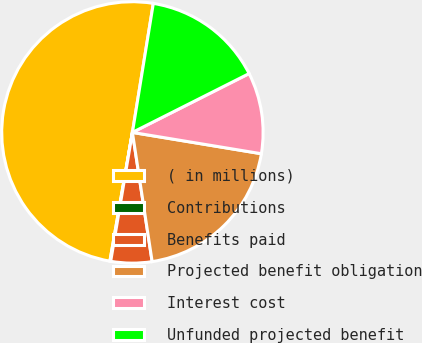Convert chart to OTSL. <chart><loc_0><loc_0><loc_500><loc_500><pie_chart><fcel>( in millions)<fcel>Contributions<fcel>Benefits paid<fcel>Projected benefit obligation<fcel>Interest cost<fcel>Unfunded projected benefit<nl><fcel>49.8%<fcel>0.1%<fcel>5.07%<fcel>19.98%<fcel>10.04%<fcel>15.01%<nl></chart> 